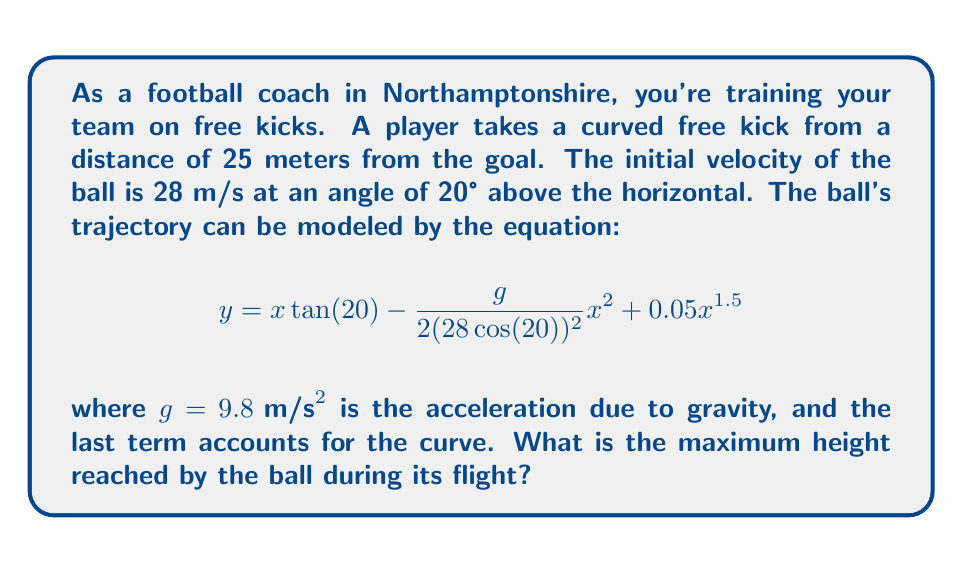Can you answer this question? To find the maximum height of the ball's trajectory, we need to follow these steps:

1) The maximum height occurs when $\frac{dy}{dx} = 0$. Let's find this derivative:

   $$\frac{dy}{dx} = \tan(20°) - \frac{g}{(28 \cos(20°))^2}x + 0.075x^{0.5}$$

2) Set this equal to zero and solve for x:

   $$\tan(20°) - \frac{g}{(28 \cos(20°))^2}x + 0.075x^{0.5} = 0$$

3) This equation is difficult to solve analytically, so we'll use numerical methods. Using a calculator or computer, we find that $x \approx 12.8$ meters.

4) Now that we know the x-coordinate of the highest point, we can plug this back into our original equation to find the maximum height:

   $$y = 12.8 \tan(20°) - \frac{9.8}{2(28 \cos(20°))^2}(12.8)^2 + 0.05(12.8)^{1.5}$$

5) Calculating this:
   
   $$y = 12.8(0.3640) - \frac{9.8}{2(26.3104)^2}(163.84) + 0.05(45.71)$$
   $$y = 4.6592 - 0.1157 + 2.2855$$
   $$y = 6.829$$

Therefore, the maximum height reached by the ball is approximately 6.83 meters.
Answer: The maximum height reached by the ball during its flight is approximately 6.83 meters. 